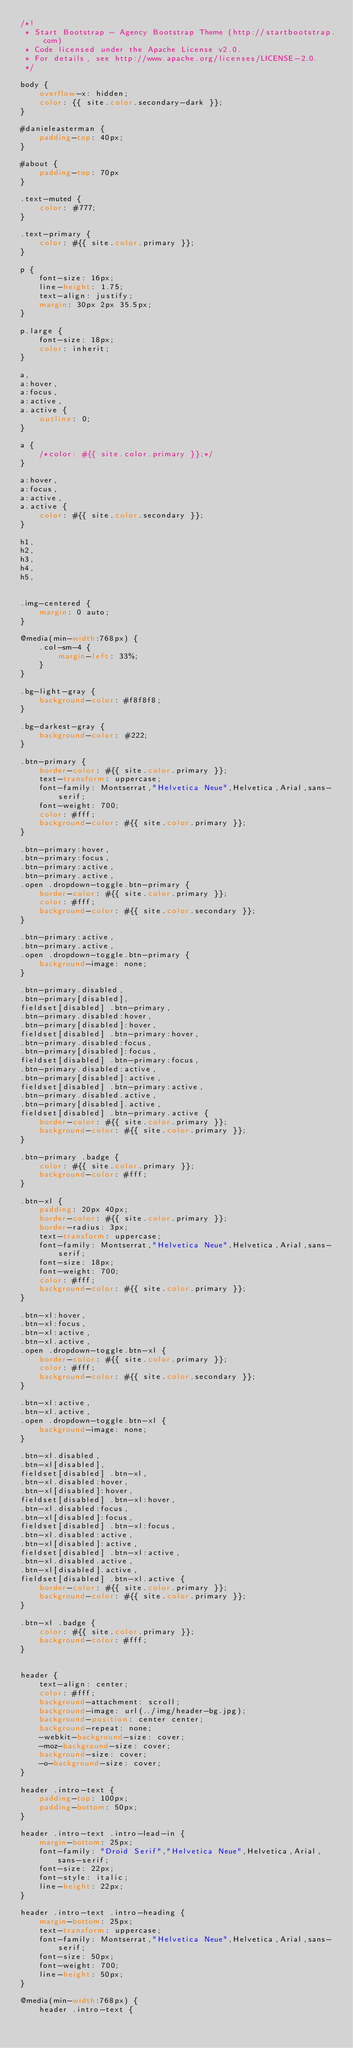<code> <loc_0><loc_0><loc_500><loc_500><_CSS_>/*!
 * Start Bootstrap - Agency Bootstrap Theme (http://startbootstrap.com)
 * Code licensed under the Apache License v2.0.
 * For details, see http://www.apache.org/licenses/LICENSE-2.0.
 */

body {
    overflow-x: hidden;
    color: {{ site.color.secondary-dark }};
}

#danieleasterman {
    padding-top: 40px;
}

#about {
    padding-top: 70px
}

.text-muted {
    color: #777;
}

.text-primary {
    color: #{{ site.color.primary }};
}

p {
    font-size: 16px;
    line-height: 1.75;
    text-align: justify;
    margin: 30px 2px 35.5px;
}

p.large {
    font-size: 18px;
    color: inherit;
}

a,
a:hover,
a:focus,
a:active,
a.active {
    outline: 0;
}

a {
    /*color: #{{ site.color.primary }};*/
}

a:hover,
a:focus,
a:active,
a.active {
    color: #{{ site.color.secondary }};
}

h1,
h2,
h3,
h4,
h5,


.img-centered {
    margin: 0 auto;
}

@media(min-width:768px) {
    .col-sm-4 {
        margin-left: 33%;
    }
}

.bg-light-gray {
    background-color: #f8f8f8;
}

.bg-darkest-gray {
    background-color: #222;
}

.btn-primary {
    border-color: #{{ site.color.primary }};
    text-transform: uppercase;
    font-family: Montserrat,"Helvetica Neue",Helvetica,Arial,sans-serif;
    font-weight: 700;
    color: #fff;
    background-color: #{{ site.color.primary }};
}

.btn-primary:hover,
.btn-primary:focus,
.btn-primary:active,
.btn-primary.active,
.open .dropdown-toggle.btn-primary {
    border-color: #{{ site.color.primary }};
    color: #fff;
    background-color: #{{ site.color.secondary }};
}

.btn-primary:active,
.btn-primary.active,
.open .dropdown-toggle.btn-primary {
    background-image: none;
}

.btn-primary.disabled,
.btn-primary[disabled],
fieldset[disabled] .btn-primary,
.btn-primary.disabled:hover,
.btn-primary[disabled]:hover,
fieldset[disabled] .btn-primary:hover,
.btn-primary.disabled:focus,
.btn-primary[disabled]:focus,
fieldset[disabled] .btn-primary:focus,
.btn-primary.disabled:active,
.btn-primary[disabled]:active,
fieldset[disabled] .btn-primary:active,
.btn-primary.disabled.active,
.btn-primary[disabled].active,
fieldset[disabled] .btn-primary.active {
    border-color: #{{ site.color.primary }};
    background-color: #{{ site.color.primary }};
}

.btn-primary .badge {
    color: #{{ site.color.primary }};
    background-color: #fff;
}

.btn-xl {
    padding: 20px 40px;
    border-color: #{{ site.color.primary }};
    border-radius: 3px;
    text-transform: uppercase;
    font-family: Montserrat,"Helvetica Neue",Helvetica,Arial,sans-serif;
    font-size: 18px;
    font-weight: 700;
    color: #fff;
    background-color: #{{ site.color.primary }};
}

.btn-xl:hover,
.btn-xl:focus,
.btn-xl:active,
.btn-xl.active,
.open .dropdown-toggle.btn-xl {
    border-color: #{{ site.color.primary }};
    color: #fff;
    background-color: #{{ site.color.secondary }};
}

.btn-xl:active,
.btn-xl.active,
.open .dropdown-toggle.btn-xl {
    background-image: none;
}

.btn-xl.disabled,
.btn-xl[disabled],
fieldset[disabled] .btn-xl,
.btn-xl.disabled:hover,
.btn-xl[disabled]:hover,
fieldset[disabled] .btn-xl:hover,
.btn-xl.disabled:focus,
.btn-xl[disabled]:focus,
fieldset[disabled] .btn-xl:focus,
.btn-xl.disabled:active,
.btn-xl[disabled]:active,
fieldset[disabled] .btn-xl:active,
.btn-xl.disabled.active,
.btn-xl[disabled].active,
fieldset[disabled] .btn-xl.active {
    border-color: #{{ site.color.primary }};
    background-color: #{{ site.color.primary }};
}

.btn-xl .badge {
    color: #{{ site.color.primary }};
    background-color: #fff;
}


header {
    text-align: center;
    color: #fff;
    background-attachment: scroll;
    background-image: url(../img/header-bg.jpg);
    background-position: center center;
    background-repeat: none;
    -webkit-background-size: cover;
    -moz-background-size: cover;
    background-size: cover;
    -o-background-size: cover;
}

header .intro-text {
    padding-top: 100px;
    padding-bottom: 50px;
}

header .intro-text .intro-lead-in {
    margin-bottom: 25px;
    font-family: "Droid Serif","Helvetica Neue",Helvetica,Arial,sans-serif;
    font-size: 22px;
    font-style: italic;
    line-height: 22px;
}

header .intro-text .intro-heading {
    margin-bottom: 25px;
    text-transform: uppercase;
    font-family: Montserrat,"Helvetica Neue",Helvetica,Arial,sans-serif;
    font-size: 50px;
    font-weight: 700;
    line-height: 50px;
}

@media(min-width:768px) {
    header .intro-text {</code> 